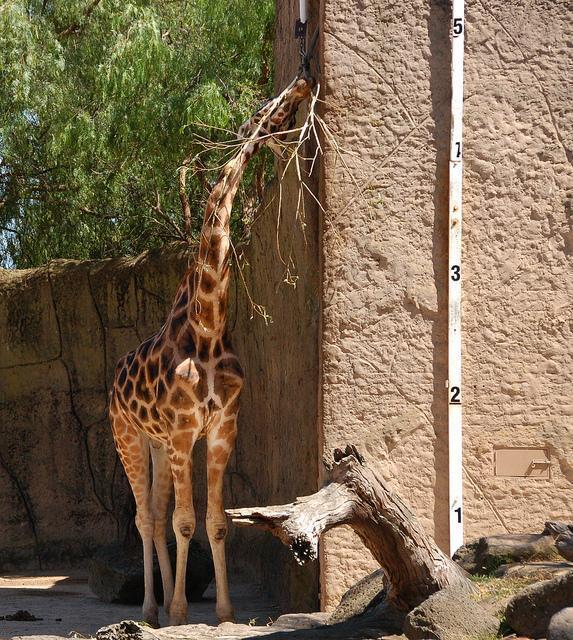How many men are smiling with teeth showing?
Give a very brief answer. 0. 